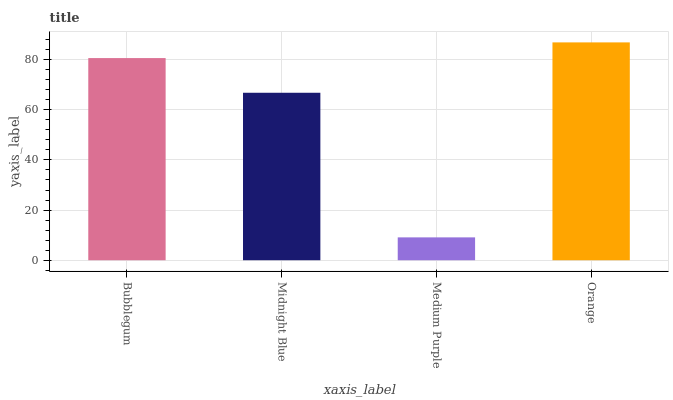Is Midnight Blue the minimum?
Answer yes or no. No. Is Midnight Blue the maximum?
Answer yes or no. No. Is Bubblegum greater than Midnight Blue?
Answer yes or no. Yes. Is Midnight Blue less than Bubblegum?
Answer yes or no. Yes. Is Midnight Blue greater than Bubblegum?
Answer yes or no. No. Is Bubblegum less than Midnight Blue?
Answer yes or no. No. Is Bubblegum the high median?
Answer yes or no. Yes. Is Midnight Blue the low median?
Answer yes or no. Yes. Is Medium Purple the high median?
Answer yes or no. No. Is Medium Purple the low median?
Answer yes or no. No. 